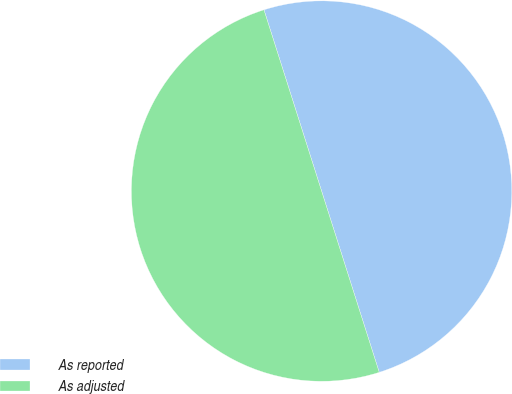Convert chart. <chart><loc_0><loc_0><loc_500><loc_500><pie_chart><fcel>As reported<fcel>As adjusted<nl><fcel>50.0%<fcel>50.0%<nl></chart> 